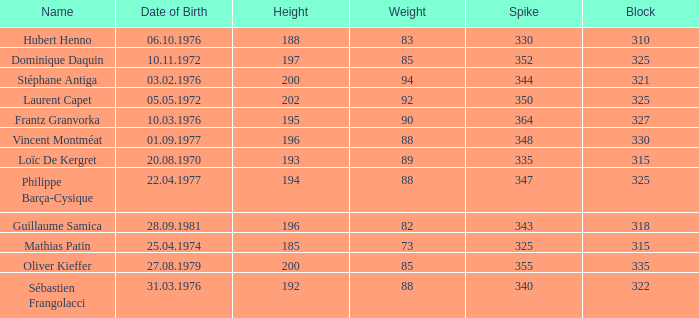How many spikes have 28.09.1981 as the date of birth, with a block greater than 318? None. 